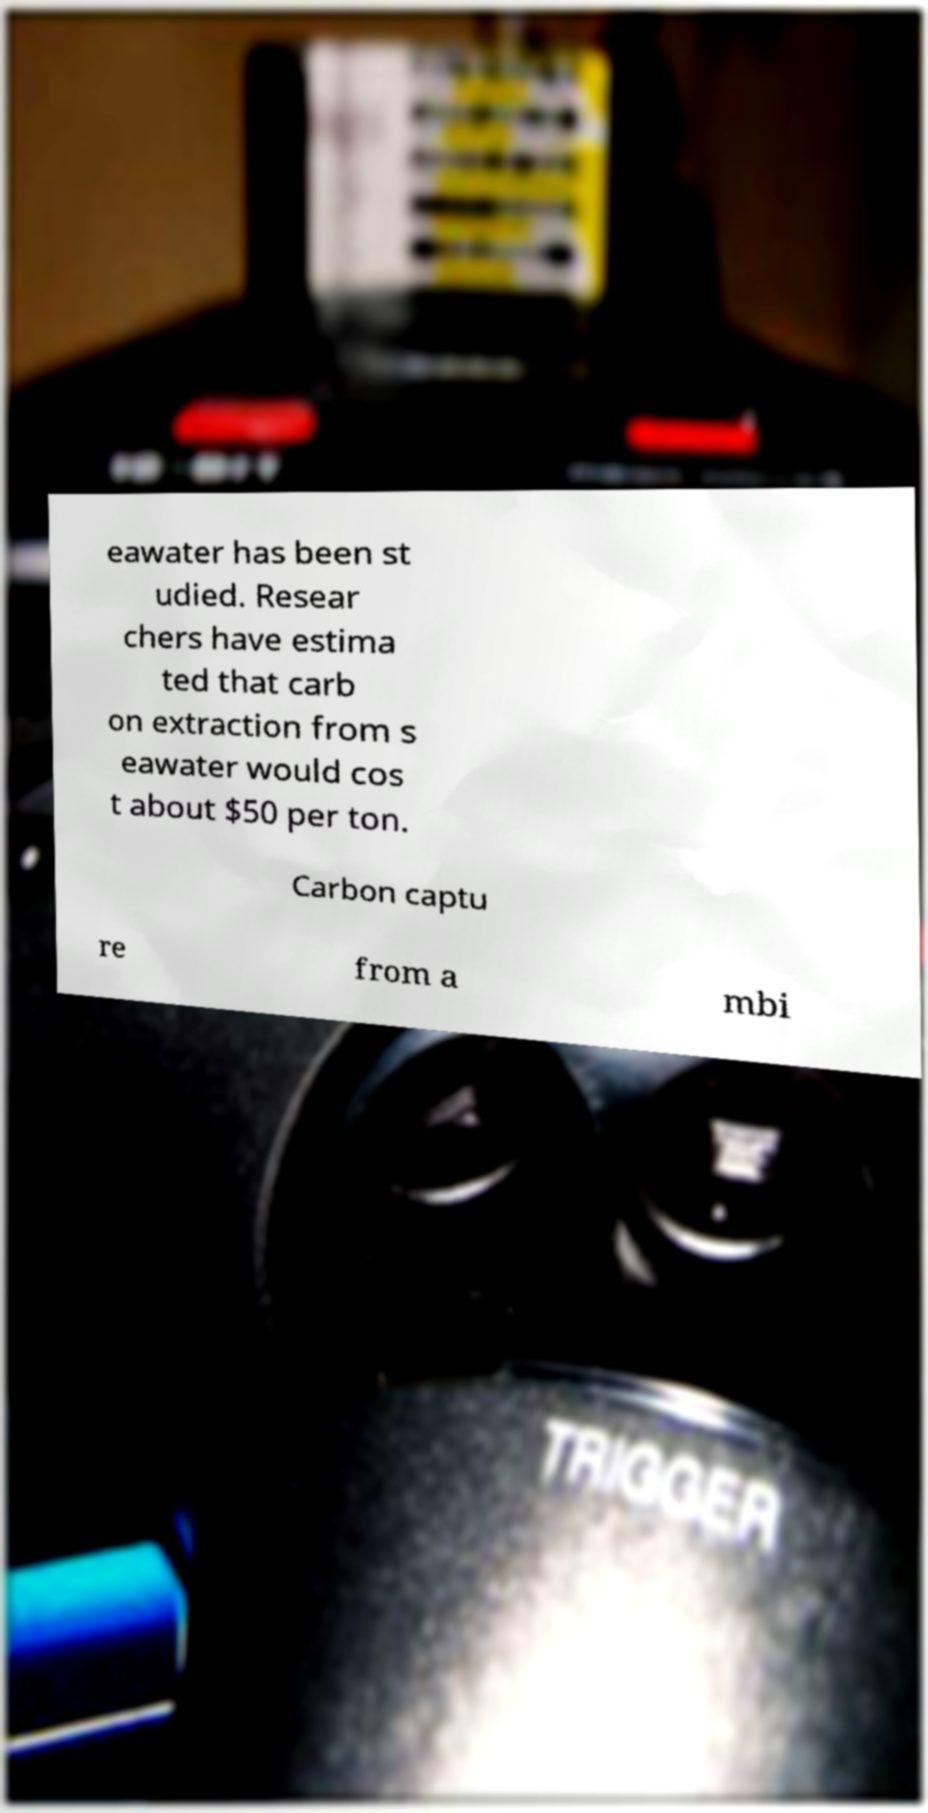There's text embedded in this image that I need extracted. Can you transcribe it verbatim? eawater has been st udied. Resear chers have estima ted that carb on extraction from s eawater would cos t about $50 per ton. Carbon captu re from a mbi 